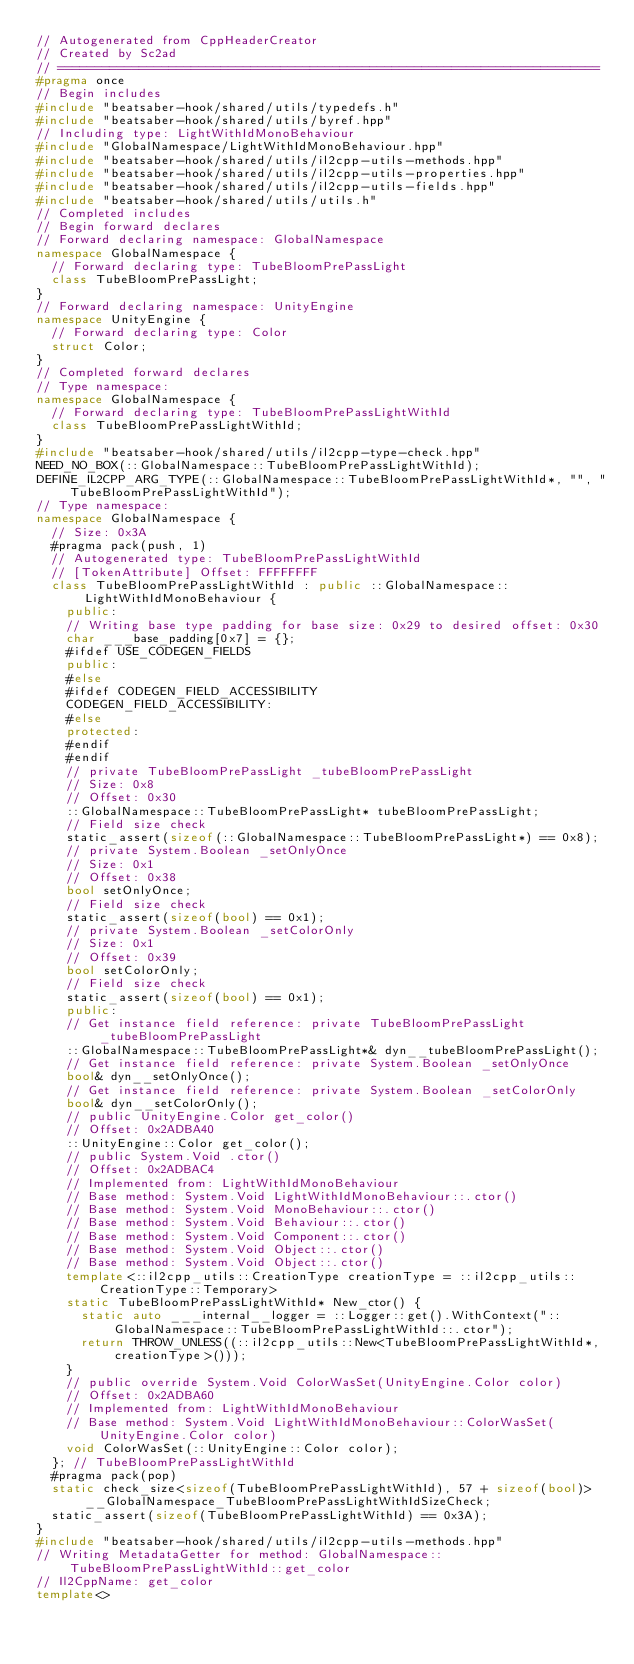<code> <loc_0><loc_0><loc_500><loc_500><_C++_>// Autogenerated from CppHeaderCreator
// Created by Sc2ad
// =========================================================================
#pragma once
// Begin includes
#include "beatsaber-hook/shared/utils/typedefs.h"
#include "beatsaber-hook/shared/utils/byref.hpp"
// Including type: LightWithIdMonoBehaviour
#include "GlobalNamespace/LightWithIdMonoBehaviour.hpp"
#include "beatsaber-hook/shared/utils/il2cpp-utils-methods.hpp"
#include "beatsaber-hook/shared/utils/il2cpp-utils-properties.hpp"
#include "beatsaber-hook/shared/utils/il2cpp-utils-fields.hpp"
#include "beatsaber-hook/shared/utils/utils.h"
// Completed includes
// Begin forward declares
// Forward declaring namespace: GlobalNamespace
namespace GlobalNamespace {
  // Forward declaring type: TubeBloomPrePassLight
  class TubeBloomPrePassLight;
}
// Forward declaring namespace: UnityEngine
namespace UnityEngine {
  // Forward declaring type: Color
  struct Color;
}
// Completed forward declares
// Type namespace: 
namespace GlobalNamespace {
  // Forward declaring type: TubeBloomPrePassLightWithId
  class TubeBloomPrePassLightWithId;
}
#include "beatsaber-hook/shared/utils/il2cpp-type-check.hpp"
NEED_NO_BOX(::GlobalNamespace::TubeBloomPrePassLightWithId);
DEFINE_IL2CPP_ARG_TYPE(::GlobalNamespace::TubeBloomPrePassLightWithId*, "", "TubeBloomPrePassLightWithId");
// Type namespace: 
namespace GlobalNamespace {
  // Size: 0x3A
  #pragma pack(push, 1)
  // Autogenerated type: TubeBloomPrePassLightWithId
  // [TokenAttribute] Offset: FFFFFFFF
  class TubeBloomPrePassLightWithId : public ::GlobalNamespace::LightWithIdMonoBehaviour {
    public:
    // Writing base type padding for base size: 0x29 to desired offset: 0x30
    char ___base_padding[0x7] = {};
    #ifdef USE_CODEGEN_FIELDS
    public:
    #else
    #ifdef CODEGEN_FIELD_ACCESSIBILITY
    CODEGEN_FIELD_ACCESSIBILITY:
    #else
    protected:
    #endif
    #endif
    // private TubeBloomPrePassLight _tubeBloomPrePassLight
    // Size: 0x8
    // Offset: 0x30
    ::GlobalNamespace::TubeBloomPrePassLight* tubeBloomPrePassLight;
    // Field size check
    static_assert(sizeof(::GlobalNamespace::TubeBloomPrePassLight*) == 0x8);
    // private System.Boolean _setOnlyOnce
    // Size: 0x1
    // Offset: 0x38
    bool setOnlyOnce;
    // Field size check
    static_assert(sizeof(bool) == 0x1);
    // private System.Boolean _setColorOnly
    // Size: 0x1
    // Offset: 0x39
    bool setColorOnly;
    // Field size check
    static_assert(sizeof(bool) == 0x1);
    public:
    // Get instance field reference: private TubeBloomPrePassLight _tubeBloomPrePassLight
    ::GlobalNamespace::TubeBloomPrePassLight*& dyn__tubeBloomPrePassLight();
    // Get instance field reference: private System.Boolean _setOnlyOnce
    bool& dyn__setOnlyOnce();
    // Get instance field reference: private System.Boolean _setColorOnly
    bool& dyn__setColorOnly();
    // public UnityEngine.Color get_color()
    // Offset: 0x2ADBA40
    ::UnityEngine::Color get_color();
    // public System.Void .ctor()
    // Offset: 0x2ADBAC4
    // Implemented from: LightWithIdMonoBehaviour
    // Base method: System.Void LightWithIdMonoBehaviour::.ctor()
    // Base method: System.Void MonoBehaviour::.ctor()
    // Base method: System.Void Behaviour::.ctor()
    // Base method: System.Void Component::.ctor()
    // Base method: System.Void Object::.ctor()
    // Base method: System.Void Object::.ctor()
    template<::il2cpp_utils::CreationType creationType = ::il2cpp_utils::CreationType::Temporary>
    static TubeBloomPrePassLightWithId* New_ctor() {
      static auto ___internal__logger = ::Logger::get().WithContext("::GlobalNamespace::TubeBloomPrePassLightWithId::.ctor");
      return THROW_UNLESS((::il2cpp_utils::New<TubeBloomPrePassLightWithId*, creationType>()));
    }
    // public override System.Void ColorWasSet(UnityEngine.Color color)
    // Offset: 0x2ADBA60
    // Implemented from: LightWithIdMonoBehaviour
    // Base method: System.Void LightWithIdMonoBehaviour::ColorWasSet(UnityEngine.Color color)
    void ColorWasSet(::UnityEngine::Color color);
  }; // TubeBloomPrePassLightWithId
  #pragma pack(pop)
  static check_size<sizeof(TubeBloomPrePassLightWithId), 57 + sizeof(bool)> __GlobalNamespace_TubeBloomPrePassLightWithIdSizeCheck;
  static_assert(sizeof(TubeBloomPrePassLightWithId) == 0x3A);
}
#include "beatsaber-hook/shared/utils/il2cpp-utils-methods.hpp"
// Writing MetadataGetter for method: GlobalNamespace::TubeBloomPrePassLightWithId::get_color
// Il2CppName: get_color
template<></code> 